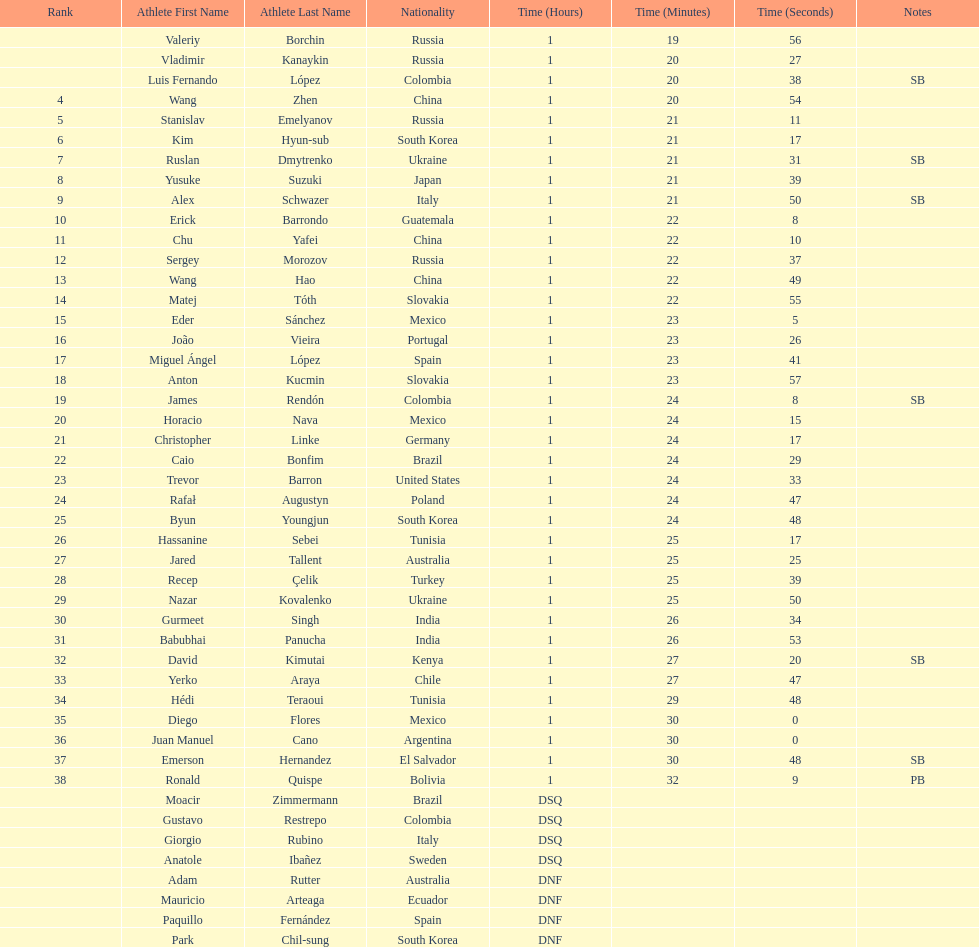Wang zhen and wang hao were both from which country? China. 